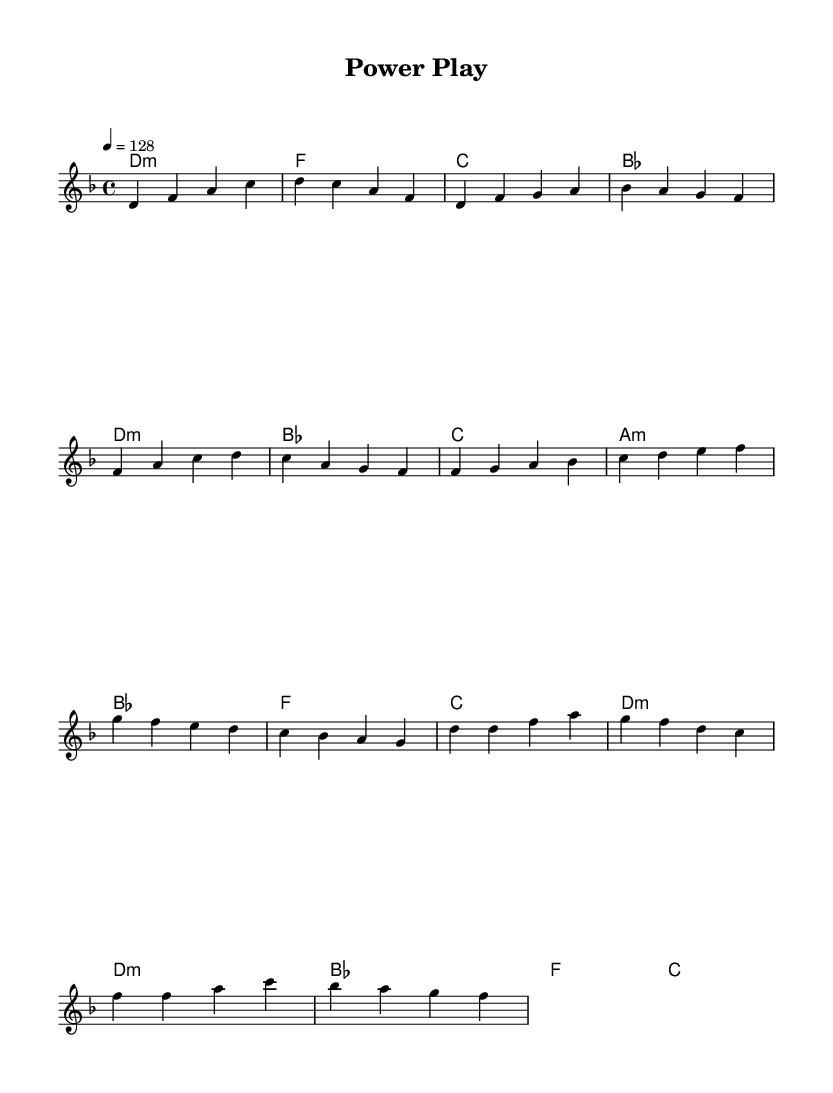What is the key signature of this music? The key signature shows two flats, indicating that the piece is in D minor. D minor has one flat, and the presence of A natural suggests the harmonic minor scale, which has a raised seventh.
Answer: D minor What is the time signature of this music? The time signature indicates four beats in each measure, which is represented by the 4/4 marking. This is common in many musical styles, including K-Pop.
Answer: 4/4 What is the tempo marking of this music? The tempo is indicated as 128 beats per minute, which is typical for an energetic K-Pop track. This fast tempo helps create a sense of urgency, suitable for high-stakes scenes.
Answer: 128 How many measures are in the Chorus section? The chorus section has four measures, which can be counted from the sheet music. Each measure is separated by vertical bar lines, making it easy to identify the structure.
Answer: 4 What chord is played in the Intro? The chords in the Intro are D minor, F major, C major, and B-flat major, matching the progression typical in many pop songs where dynamic contrasts are created.
Answer: D minor What are the starting notes of the Verse section? The starting notes of the Verse section are D, F, and G, following the melody as shown. These notes establish the thematic material for this part of the song.
Answer: D F G Is there a pre-chorus in this piece? Yes, the sheet music includes a pre-chorus section, identifiable by its distinct melody and chord progression leading into the chorus. This structural component is common in K-Pop arrangements.
Answer: Yes 